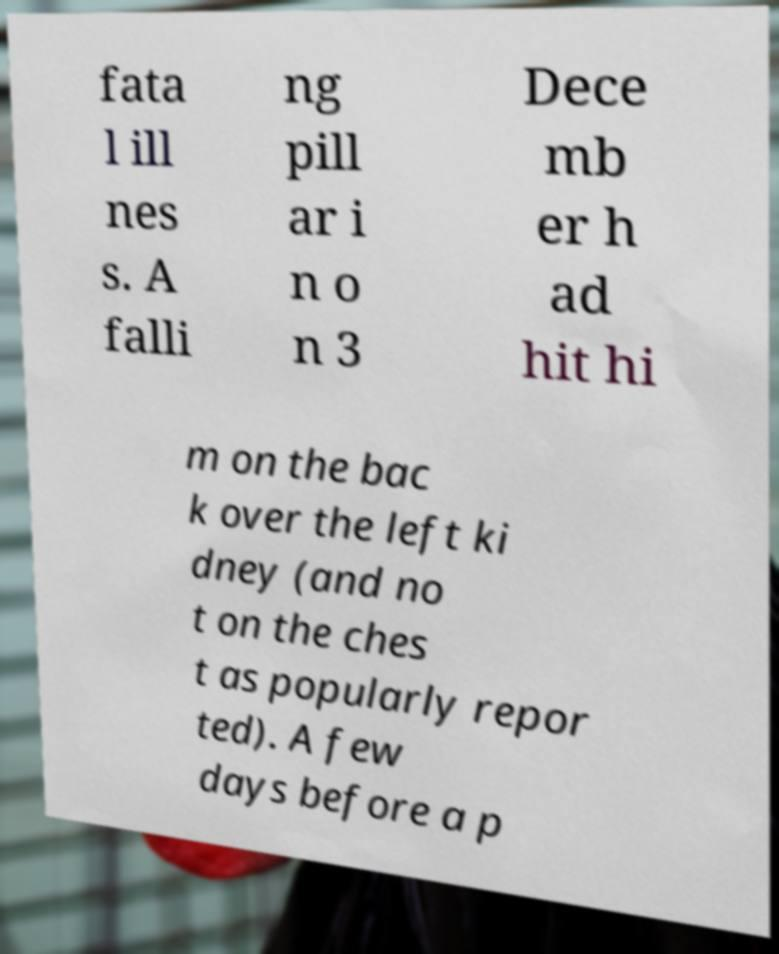Please read and relay the text visible in this image. What does it say? fata l ill nes s. A falli ng pill ar i n o n 3 Dece mb er h ad hit hi m on the bac k over the left ki dney (and no t on the ches t as popularly repor ted). A few days before a p 